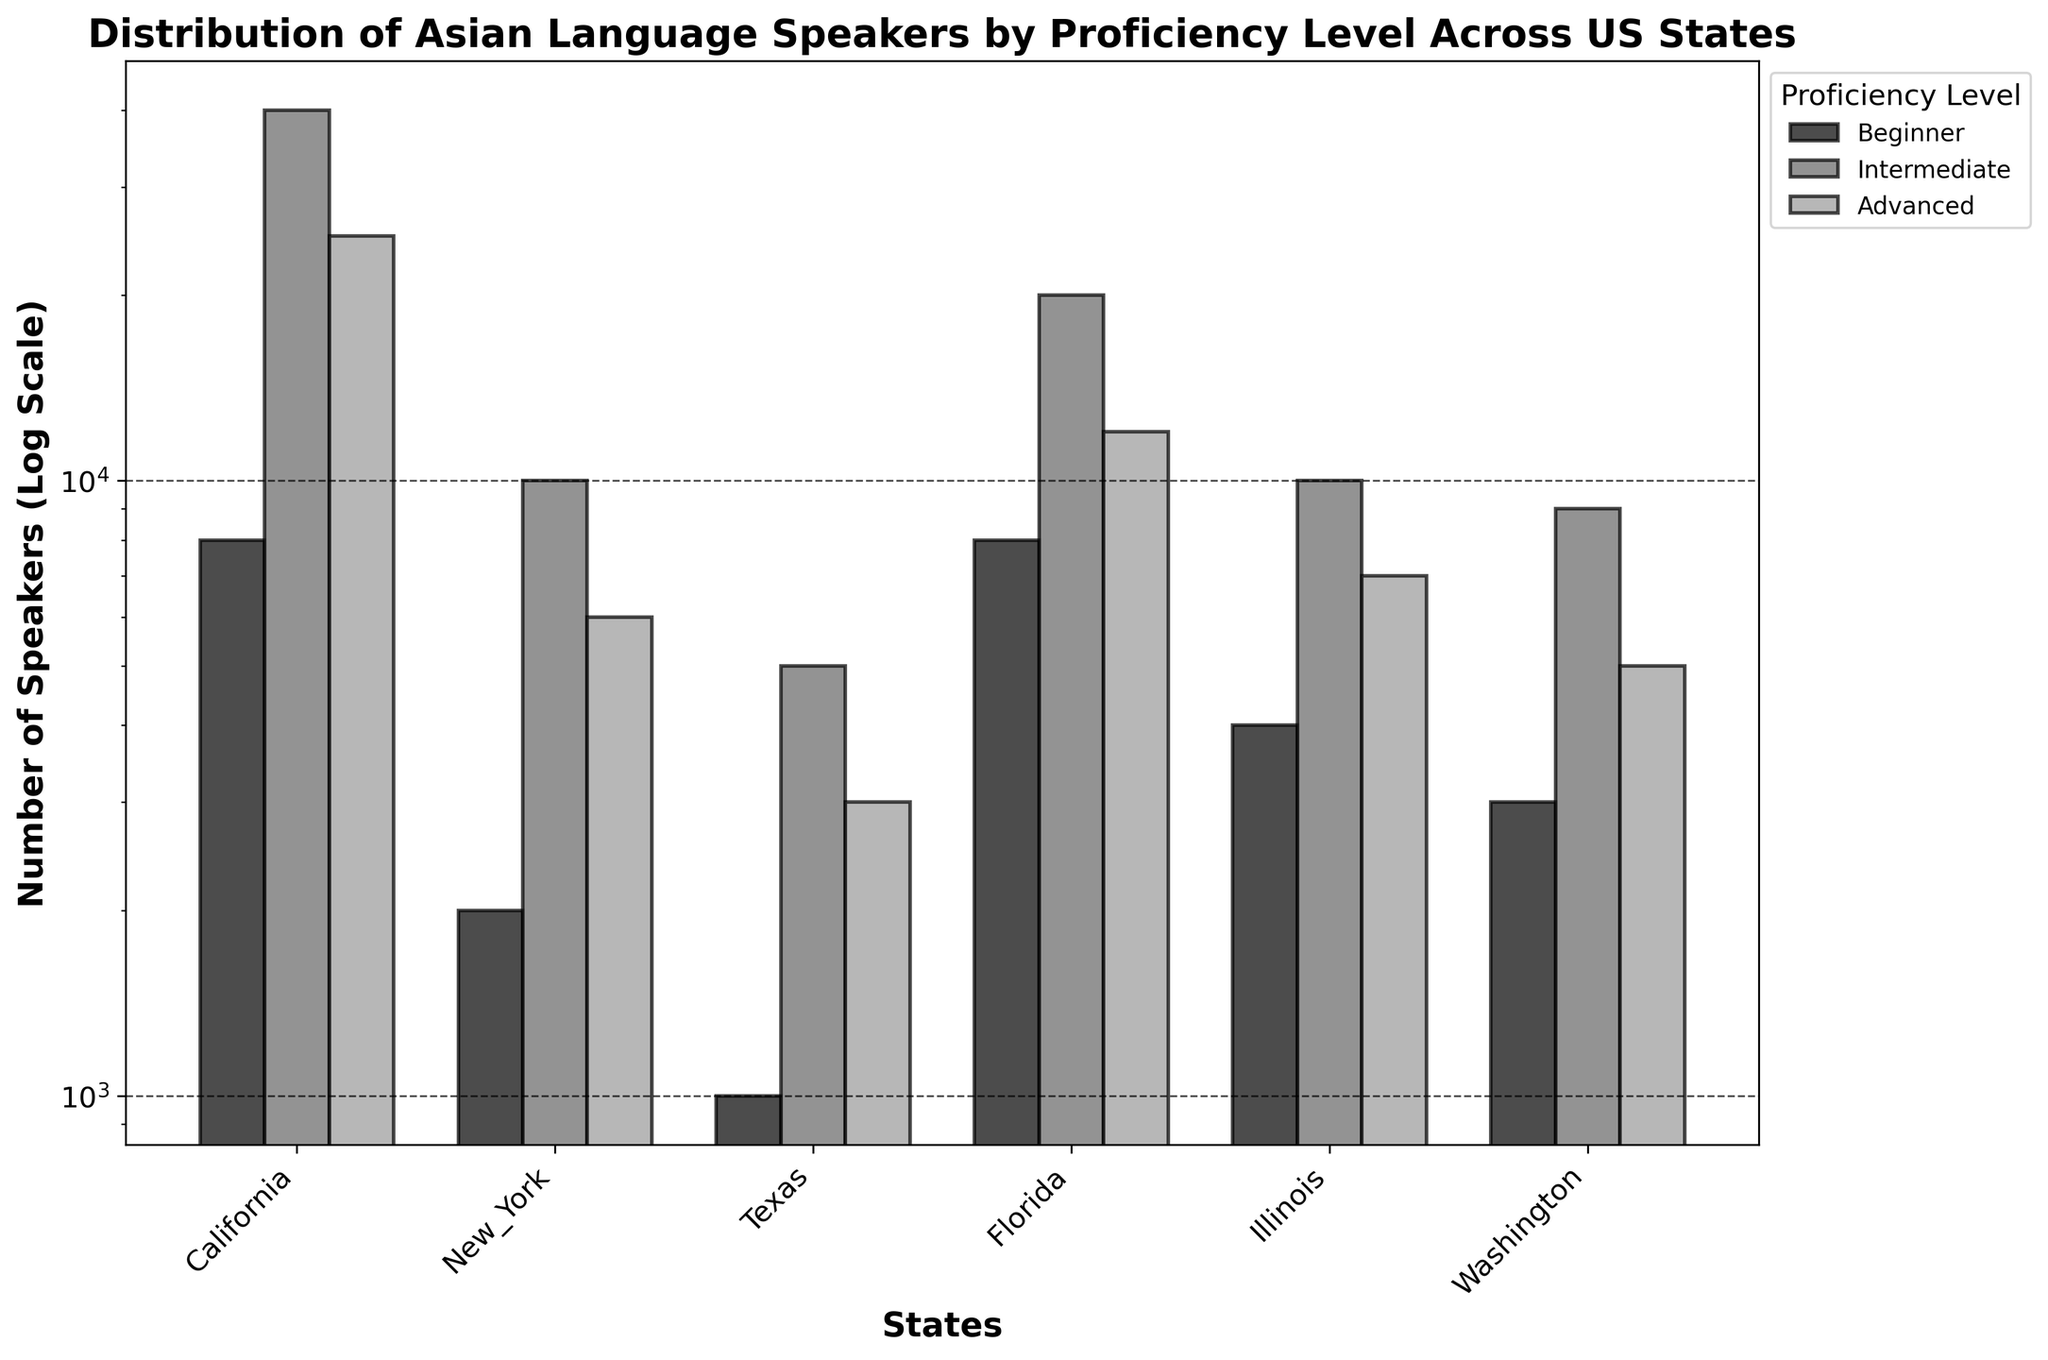How many states are included in the plot? The figure shows the distribution of Asian language speakers across different US states, and we can count the number of unique state labels on the x-axis. The states are California, New York, Texas, Florida, Illinois, and Washington.
Answer: 6 Which state has the highest number of Mandarin speakers at the intermediate level? By looking at the bars for the intermediate level and identifying the tallest bar for Mandarin speakers, we observe that California has the highest number of Mandarin speakers at the intermediate level.
Answer: California Compare the number of advanced Tagalog speakers in Florida to advanced Vietnamese speakers in Illinois. Which state has more and by how much? The heights of the bars representing the advanced level speakers of Tagalog in Florida and Vietnamese in Illinois are compared. Florida has 12,000 advanced Tagalog speakers, while Illinois has 7,000 advanced Vietnamese speakers. The difference is 12,000 - 7,000 = 5,000.
Answer: Florida by 5,000 What is the total number of speakers of all Asian languages at the beginner level in California? Sum up the numbers of beginner level speakers for all Asian languages in California: Mandarin (5,000) + Hindi (3,000). So, the total is 5,000 + 3,000 = 8,000.
Answer: 8,000 Which proficiency level has the least number of Filipino speakers in Washington? By comparing the heights of the bars for each proficiency level for Filipino speakers in Washington, the beginner, intermediate, and advanced levels are displayed. The beginner level bar is the shortest.
Answer: Beginner By how much do the intermediate Hindi speakers in California exceed the intermediate Korean speakers in New York? Compare the number of intermediate level speakers of Hindi in California (15,000) and Korean in New York (10,000). The difference is 15,000 - 10,000 = 5,000.
Answer: 5,000 What is the sum of intermediate speakers for all languages in Texas? Adding the intermediate level speakers of all Asian languages in Texas: Japanese (5,000). The total is 5,000.
Answer: 5,000 Which state has the lowest total number of Asian language speakers across all proficiency levels? Summing up the number of speakers for each proficiency level in each state and identifying the state with the lowest total: California (5k+25k+15k+3k+15k+10k), New York (2k+10k+6k), Texas (1k+5k+3k), Florida (8k+20k+12k), Illinois (4k+10k+7k), and Washington (3k+9k+5k). Texas has the lowest total.
Answer: Texas Does New York have more beginner or advanced Korean speakers, and by how much? Comparing the height of the bars for beginner and advanced Korean speakers in New York. Beginner level has 2,000, and advanced level has 6,000. Advanced speakers exceed beginner by 6,000 - 2,000 = 4,000.
Answer: Advanced by 4,000 